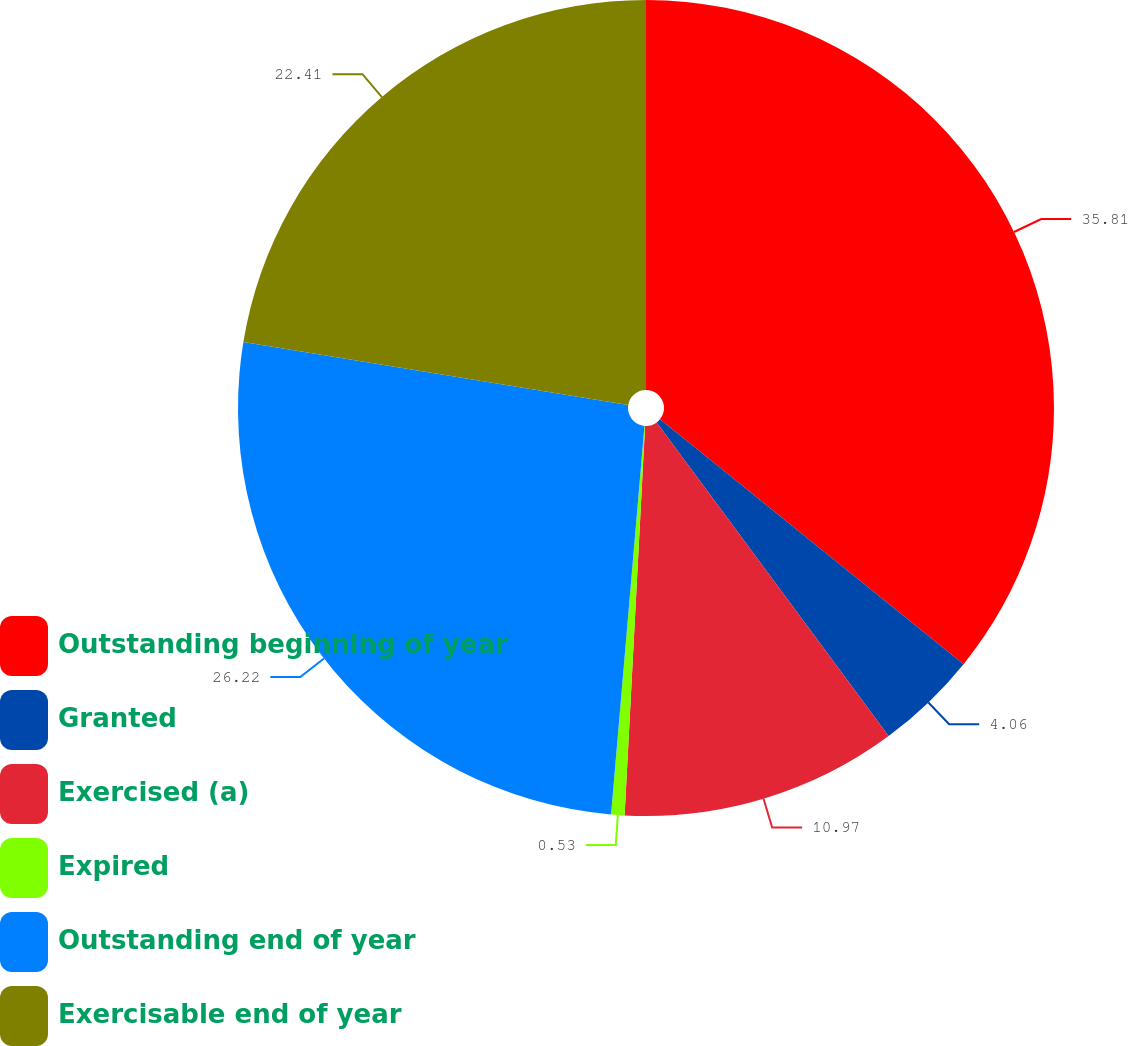Convert chart to OTSL. <chart><loc_0><loc_0><loc_500><loc_500><pie_chart><fcel>Outstanding beginning of year<fcel>Granted<fcel>Exercised (a)<fcel>Expired<fcel>Outstanding end of year<fcel>Exercisable end of year<nl><fcel>35.8%<fcel>4.06%<fcel>10.97%<fcel>0.53%<fcel>26.22%<fcel>22.41%<nl></chart> 